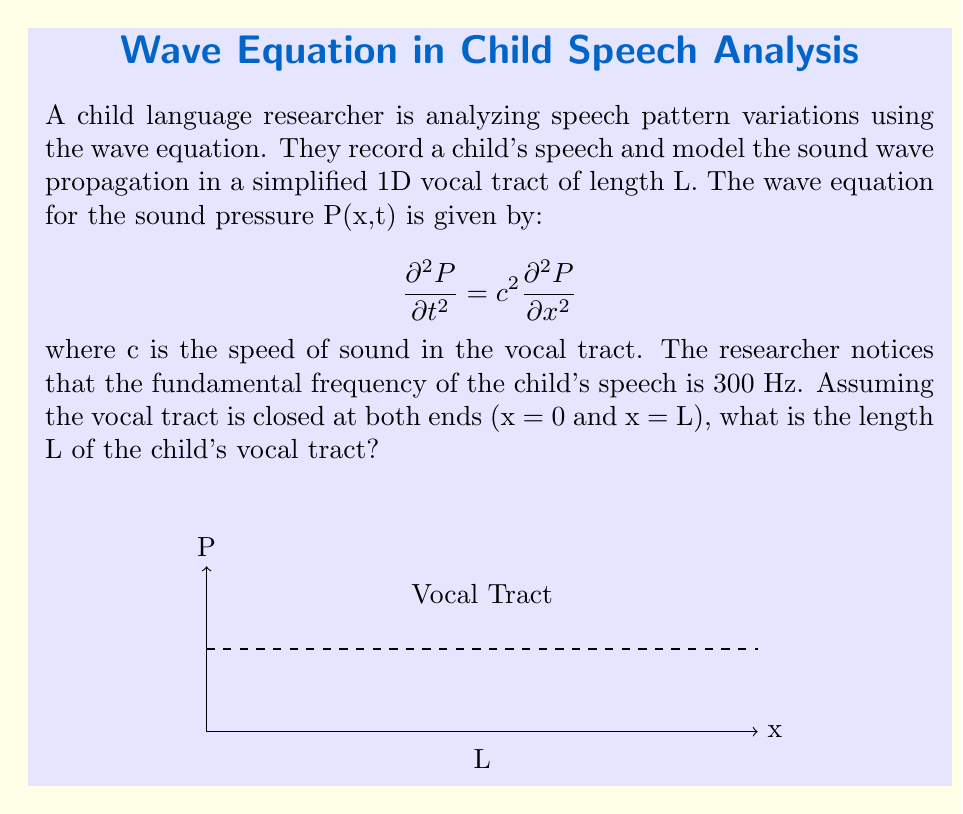Give your solution to this math problem. Let's approach this step-by-step:

1) For a wave in a pipe closed at both ends, we have standing waves with nodes at both ends. The fundamental frequency corresponds to the first harmonic, where the wavelength λ is twice the length of the pipe:

   $$L = \frac{\lambda}{2}$$

2) We know the relation between wave speed (c), frequency (f), and wavelength (λ):

   $$c = f\lambda$$

3) Rearranging this equation for λ:

   $$\lambda = \frac{c}{f}$$

4) Substituting this into our equation for L:

   $$L = \frac{c}{2f}$$

5) We're given that f = 300 Hz. The speed of sound in air at room temperature is approximately 343 m/s, but it's slightly higher in the warm, moist air of the vocal tract. Let's use c ≈ 350 m/s.

6) Plugging in our values:

   $$L = \frac{350 \text{ m/s}}{2(300 \text{ Hz})} = \frac{350}{600} \text{ m} \approx 0.583 \text{ m}$$

7) Converting to centimeters:

   $$L \approx 58.3 \text{ cm}$$

This length is too long for a child's vocal tract, suggesting that we should consider the possibility of higher harmonics. If we assume the 300 Hz frequency corresponds to the second harmonic, we would divide our result by 2:

$$L \approx 29.2 \text{ cm}$$

This is a more realistic length for a child's vocal tract.
Answer: $L \approx 29.2 \text{ cm}$ 